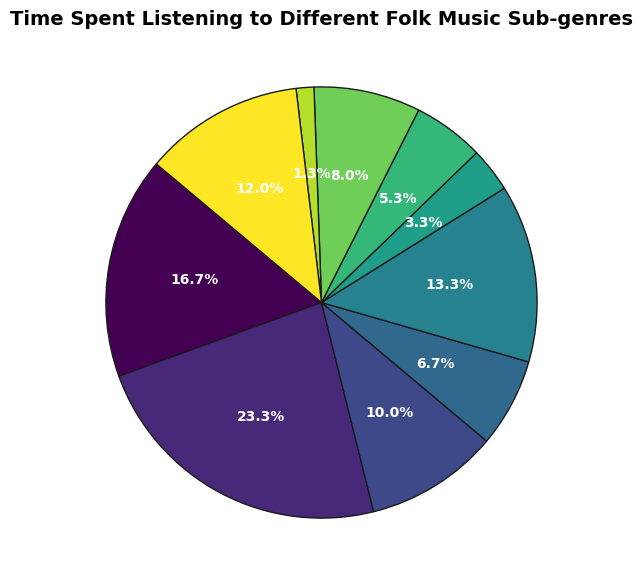Which sub-genre has the highest percentage of time spent listening? The largest wedge in the pie chart represents the time spent listening to Traditional Irish, which takes up the largest portion of the chart.
Answer: Traditional Irish What is the combined percentage of time spent on Bluegrass and Folk Punk? Add the percentages of Bluegrass (5 hours) and Folk Punk (2 hours). The combined time is 5+2=7 hours. Calculate the percentage: (7/150) * 100 = 4.67%
Answer: 4.67% Which two sub-genres have the closest amounts of time spent listening? Contemporary Folk (15 hours) and Folk Revival (12 hours) have the most similar amounts of time spent, with a difference of 3 hours.
Answer: Contemporary Folk and Folk Revival What is the difference in percentage between the sub-genre with the highest and lowest time spent listening? The highest is Traditional Irish at 35 hours and the lowest is Folk Punk at 2 hours. Difference in hours = 35 - 2 = 33 hours. Calculate the percentage: (33/150) * 100 = 22%
Answer: 22% What is the total percentage of time spent on Traditional Irish and British Folk combined? Add the times for Traditional Irish (35 hours) and British Folk (20 hours). Combined time = 35 + 20 = 55 hours. Calculate the percentage: (55/150) * 100 = 36.67%
Answer: 36.67% Which sub-genre has nearly half the listening time of Celtic Folk? Celtic Folk has 25 hours. Half of 25 is 12.5. The closest sub-genre is Folk Revival with 12 hours.
Answer: Folk Revival How does the time spent on American Folk compare to British Folk? American Folk has 18 hours and British Folk has 20 hours. British Folk has 2 hours more.
Answer: British Folk is 2 hours more What is the average time spent on the three least listened-to sub-genres? The least listened-to sub-genres are Folk Punk (2 hours), Bluegrass (5 hours), and Appalachian (8 hours). The sum is 2 + 5 + 8 = 15 hours. The average is 15/3 = 5 hours.
Answer: 5 hours Which sub-genre occupies the most visually significant wedge in green? The pie chart uses colors from light to dark green. The largest green wedge represents Traditional Irish.
Answer: Traditional Irish What is the combined listening time for Nordic Folk and Appalachian Folk, and what percentage of the total does this represent? Add the times for Nordic Folk (10 hours) and Appalachian (8 hours). Combined time = 10 + 8 = 18 hours. Calculate the percentage: (18/150) * 100 = 12%
Answer: 12% 